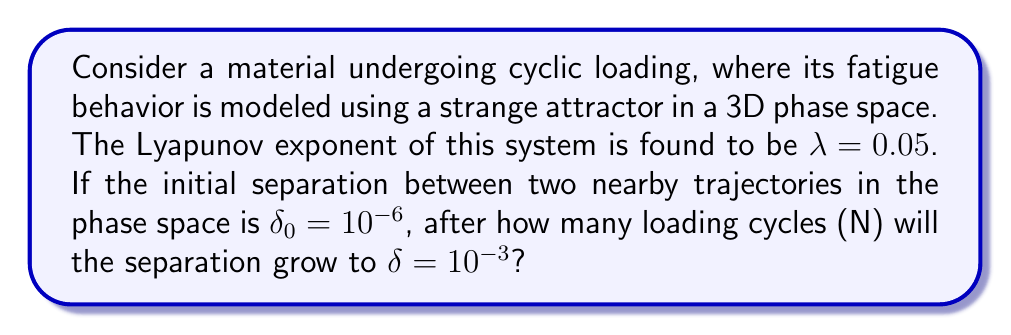Can you answer this question? To solve this problem, we'll use the concept of Lyapunov exponents from chaos theory:

1. The Lyapunov exponent $\lambda$ describes the rate of separation of infinitesimally close trajectories in a dynamical system. In this case, it represents the rate at which material fatigue progresses.

2. The relationship between initial separation $\delta_0$, final separation $\delta$, number of cycles $N$, and Lyapunov exponent $\lambda$ is given by:

   $$\delta = \delta_0 e^{\lambda N}$$

3. We need to solve for $N$. Let's take the natural logarithm of both sides:

   $$\ln(\delta) = \ln(\delta_0) + \lambda N$$

4. Rearrange to isolate $N$:

   $$N = \frac{\ln(\delta) - \ln(\delta_0)}{\lambda}$$

5. Now, let's substitute the given values:
   $\delta = 10^{-3}$
   $\delta_0 = 10^{-6}$
   $\lambda = 0.05$

   $$N = \frac{\ln(10^{-3}) - \ln(10^{-6})}{0.05}$$

6. Simplify:
   $$N = \frac{-6.91 - (-13.82)}{0.05} = \frac{6.91}{0.05} = 138.2$$

7. Since we're dealing with loading cycles, we need to round up to the nearest whole number.
Answer: 139 cycles 